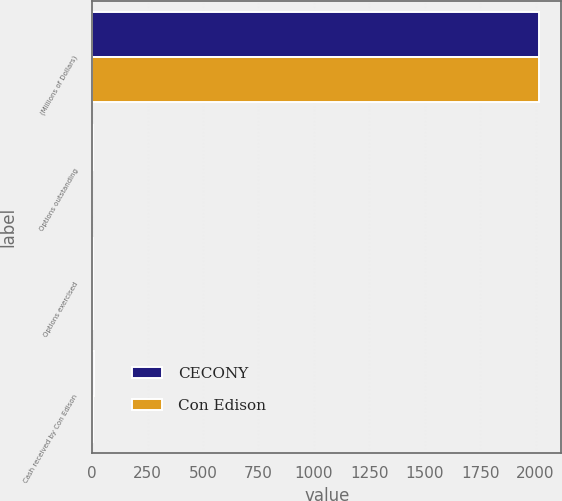<chart> <loc_0><loc_0><loc_500><loc_500><stacked_bar_chart><ecel><fcel>(Millions of Dollars)<fcel>Options outstanding<fcel>Options exercised<fcel>Cash received by Con Edison<nl><fcel>CECONY<fcel>2015<fcel>2<fcel>3<fcel>6<nl><fcel>Con Edison<fcel>2015<fcel>1<fcel>3<fcel>5<nl></chart> 